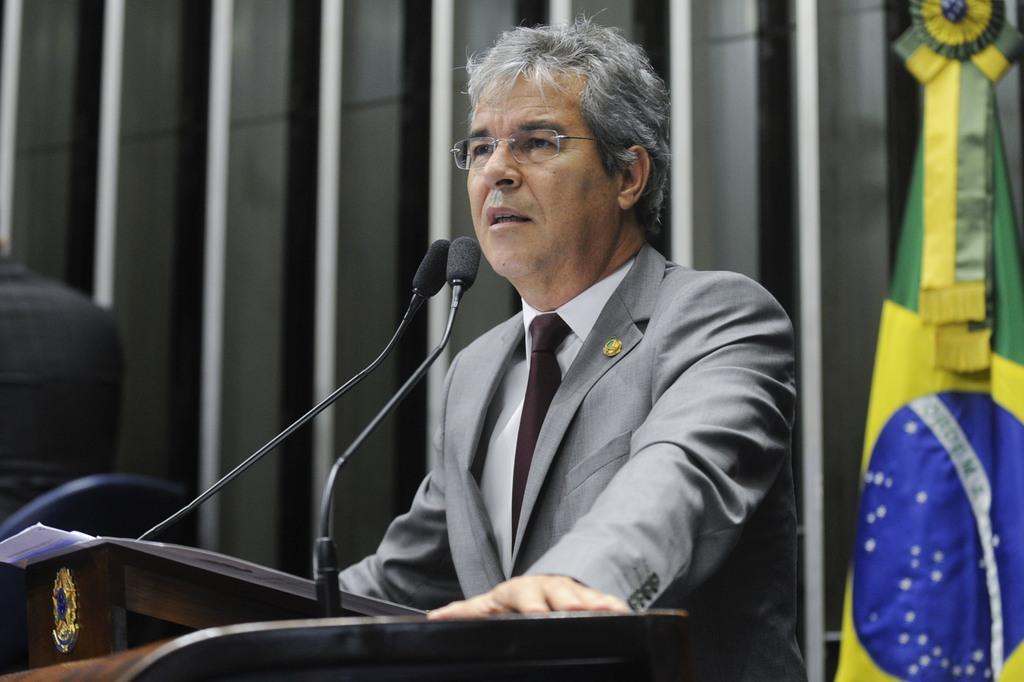How would you summarize this image in a sentence or two? In this image we can see a man standing beside a speaker stand containing some papers and the miles on it. On the right side we can see the flag. On the backside we can see a person sitting on a chair and some metal poles. 